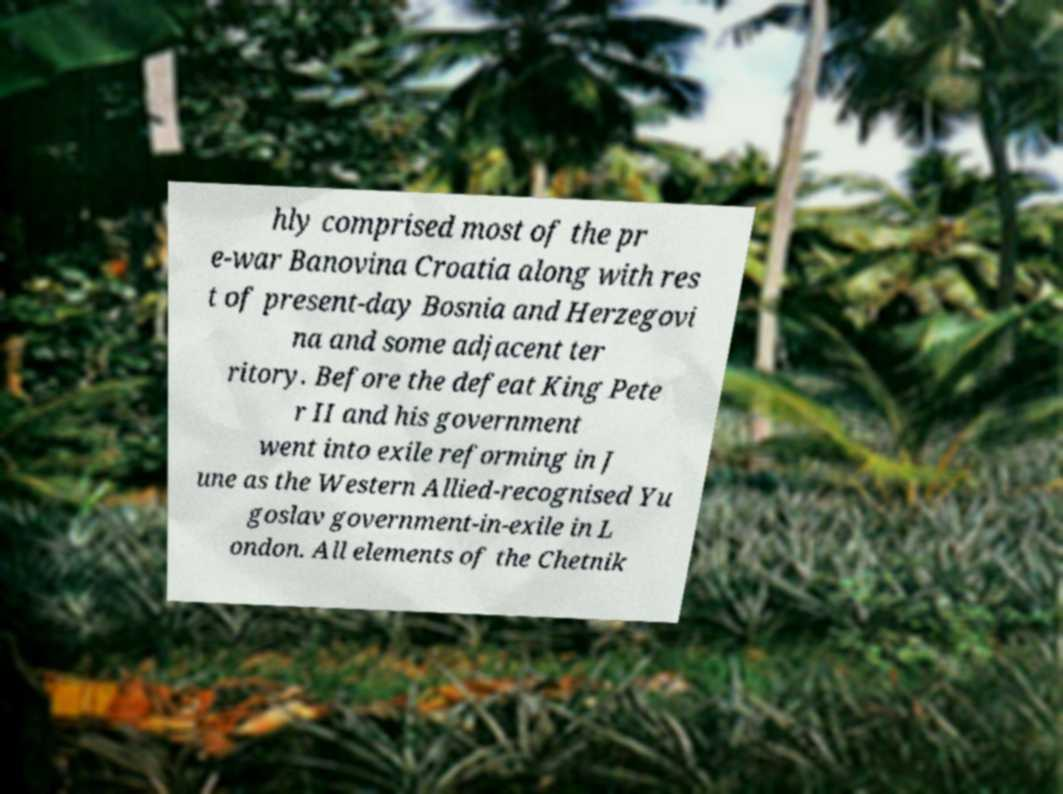For documentation purposes, I need the text within this image transcribed. Could you provide that? hly comprised most of the pr e-war Banovina Croatia along with res t of present-day Bosnia and Herzegovi na and some adjacent ter ritory. Before the defeat King Pete r II and his government went into exile reforming in J une as the Western Allied-recognised Yu goslav government-in-exile in L ondon. All elements of the Chetnik 